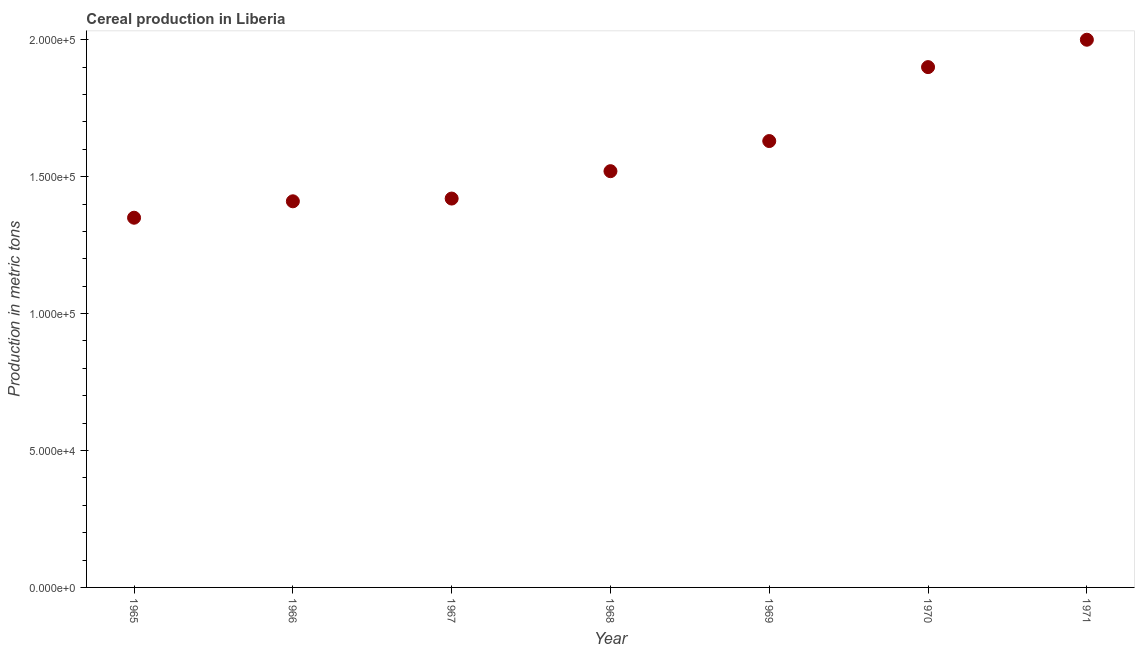What is the cereal production in 1966?
Give a very brief answer. 1.41e+05. Across all years, what is the maximum cereal production?
Ensure brevity in your answer.  2.00e+05. Across all years, what is the minimum cereal production?
Make the answer very short. 1.35e+05. In which year was the cereal production maximum?
Provide a succinct answer. 1971. In which year was the cereal production minimum?
Offer a very short reply. 1965. What is the sum of the cereal production?
Your response must be concise. 1.12e+06. What is the difference between the cereal production in 1968 and 1971?
Give a very brief answer. -4.80e+04. What is the average cereal production per year?
Provide a succinct answer. 1.60e+05. What is the median cereal production?
Your response must be concise. 1.52e+05. In how many years, is the cereal production greater than 130000 metric tons?
Ensure brevity in your answer.  7. What is the ratio of the cereal production in 1965 to that in 1969?
Ensure brevity in your answer.  0.83. Is the cereal production in 1968 less than that in 1969?
Offer a terse response. Yes. Is the difference between the cereal production in 1965 and 1968 greater than the difference between any two years?
Ensure brevity in your answer.  No. What is the difference between the highest and the second highest cereal production?
Your response must be concise. 10000. What is the difference between the highest and the lowest cereal production?
Give a very brief answer. 6.50e+04. How many dotlines are there?
Offer a very short reply. 1. How many years are there in the graph?
Provide a short and direct response. 7. What is the difference between two consecutive major ticks on the Y-axis?
Make the answer very short. 5.00e+04. What is the title of the graph?
Ensure brevity in your answer.  Cereal production in Liberia. What is the label or title of the X-axis?
Give a very brief answer. Year. What is the label or title of the Y-axis?
Your answer should be compact. Production in metric tons. What is the Production in metric tons in 1965?
Offer a very short reply. 1.35e+05. What is the Production in metric tons in 1966?
Provide a short and direct response. 1.41e+05. What is the Production in metric tons in 1967?
Keep it short and to the point. 1.42e+05. What is the Production in metric tons in 1968?
Your answer should be very brief. 1.52e+05. What is the Production in metric tons in 1969?
Make the answer very short. 1.63e+05. What is the Production in metric tons in 1970?
Make the answer very short. 1.90e+05. What is the difference between the Production in metric tons in 1965 and 1966?
Offer a terse response. -6000. What is the difference between the Production in metric tons in 1965 and 1967?
Give a very brief answer. -7000. What is the difference between the Production in metric tons in 1965 and 1968?
Provide a short and direct response. -1.70e+04. What is the difference between the Production in metric tons in 1965 and 1969?
Give a very brief answer. -2.80e+04. What is the difference between the Production in metric tons in 1965 and 1970?
Your answer should be compact. -5.50e+04. What is the difference between the Production in metric tons in 1965 and 1971?
Offer a very short reply. -6.50e+04. What is the difference between the Production in metric tons in 1966 and 1967?
Offer a terse response. -1000. What is the difference between the Production in metric tons in 1966 and 1968?
Keep it short and to the point. -1.10e+04. What is the difference between the Production in metric tons in 1966 and 1969?
Keep it short and to the point. -2.20e+04. What is the difference between the Production in metric tons in 1966 and 1970?
Provide a short and direct response. -4.90e+04. What is the difference between the Production in metric tons in 1966 and 1971?
Offer a very short reply. -5.90e+04. What is the difference between the Production in metric tons in 1967 and 1968?
Provide a short and direct response. -10000. What is the difference between the Production in metric tons in 1967 and 1969?
Ensure brevity in your answer.  -2.10e+04. What is the difference between the Production in metric tons in 1967 and 1970?
Your answer should be compact. -4.80e+04. What is the difference between the Production in metric tons in 1967 and 1971?
Give a very brief answer. -5.80e+04. What is the difference between the Production in metric tons in 1968 and 1969?
Your answer should be compact. -1.10e+04. What is the difference between the Production in metric tons in 1968 and 1970?
Give a very brief answer. -3.80e+04. What is the difference between the Production in metric tons in 1968 and 1971?
Ensure brevity in your answer.  -4.80e+04. What is the difference between the Production in metric tons in 1969 and 1970?
Your response must be concise. -2.70e+04. What is the difference between the Production in metric tons in 1969 and 1971?
Your response must be concise. -3.70e+04. What is the ratio of the Production in metric tons in 1965 to that in 1967?
Your answer should be compact. 0.95. What is the ratio of the Production in metric tons in 1965 to that in 1968?
Provide a short and direct response. 0.89. What is the ratio of the Production in metric tons in 1965 to that in 1969?
Your answer should be very brief. 0.83. What is the ratio of the Production in metric tons in 1965 to that in 1970?
Offer a very short reply. 0.71. What is the ratio of the Production in metric tons in 1965 to that in 1971?
Make the answer very short. 0.68. What is the ratio of the Production in metric tons in 1966 to that in 1968?
Offer a very short reply. 0.93. What is the ratio of the Production in metric tons in 1966 to that in 1969?
Your answer should be very brief. 0.86. What is the ratio of the Production in metric tons in 1966 to that in 1970?
Offer a terse response. 0.74. What is the ratio of the Production in metric tons in 1966 to that in 1971?
Provide a short and direct response. 0.7. What is the ratio of the Production in metric tons in 1967 to that in 1968?
Offer a terse response. 0.93. What is the ratio of the Production in metric tons in 1967 to that in 1969?
Your answer should be compact. 0.87. What is the ratio of the Production in metric tons in 1967 to that in 1970?
Offer a very short reply. 0.75. What is the ratio of the Production in metric tons in 1967 to that in 1971?
Provide a succinct answer. 0.71. What is the ratio of the Production in metric tons in 1968 to that in 1969?
Your answer should be compact. 0.93. What is the ratio of the Production in metric tons in 1968 to that in 1971?
Make the answer very short. 0.76. What is the ratio of the Production in metric tons in 1969 to that in 1970?
Make the answer very short. 0.86. What is the ratio of the Production in metric tons in 1969 to that in 1971?
Your answer should be compact. 0.81. 